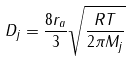Convert formula to latex. <formula><loc_0><loc_0><loc_500><loc_500>D _ { j } = \frac { 8 r _ { a } } { 3 } \sqrt { \frac { R T } { 2 \pi M _ { j } } }</formula> 